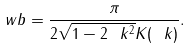Convert formula to latex. <formula><loc_0><loc_0><loc_500><loc_500>\ w b = \frac { \pi } { 2 \sqrt { 1 - 2 \ k ^ { 2 } } K ( \ k ) } .</formula> 